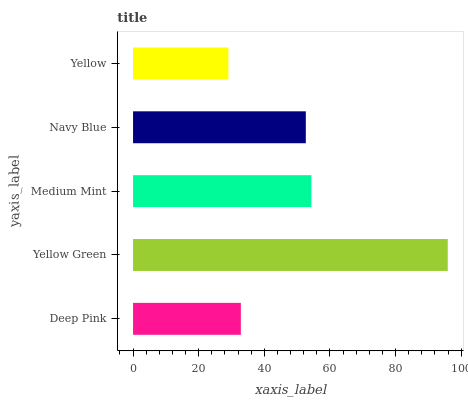Is Yellow the minimum?
Answer yes or no. Yes. Is Yellow Green the maximum?
Answer yes or no. Yes. Is Medium Mint the minimum?
Answer yes or no. No. Is Medium Mint the maximum?
Answer yes or no. No. Is Yellow Green greater than Medium Mint?
Answer yes or no. Yes. Is Medium Mint less than Yellow Green?
Answer yes or no. Yes. Is Medium Mint greater than Yellow Green?
Answer yes or no. No. Is Yellow Green less than Medium Mint?
Answer yes or no. No. Is Navy Blue the high median?
Answer yes or no. Yes. Is Navy Blue the low median?
Answer yes or no. Yes. Is Deep Pink the high median?
Answer yes or no. No. Is Yellow Green the low median?
Answer yes or no. No. 